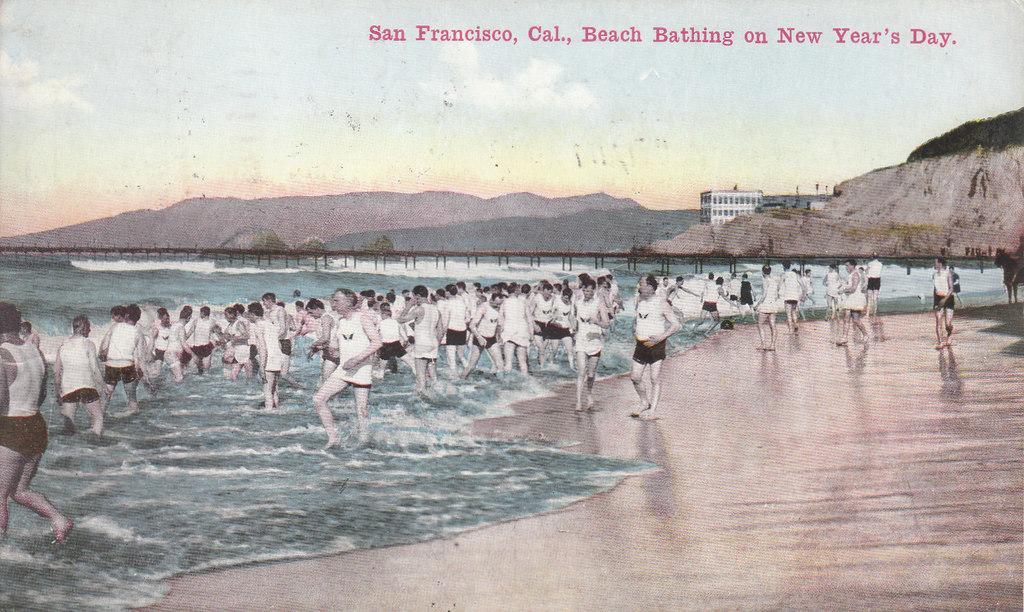How would you summarize this image in a sentence or two? In this image we can see many people. There is water. In the back there is a bridge with pillars. On the right side there is a hill. In the background there is a building. Also there are hills and sky. Also something is written at the top. 